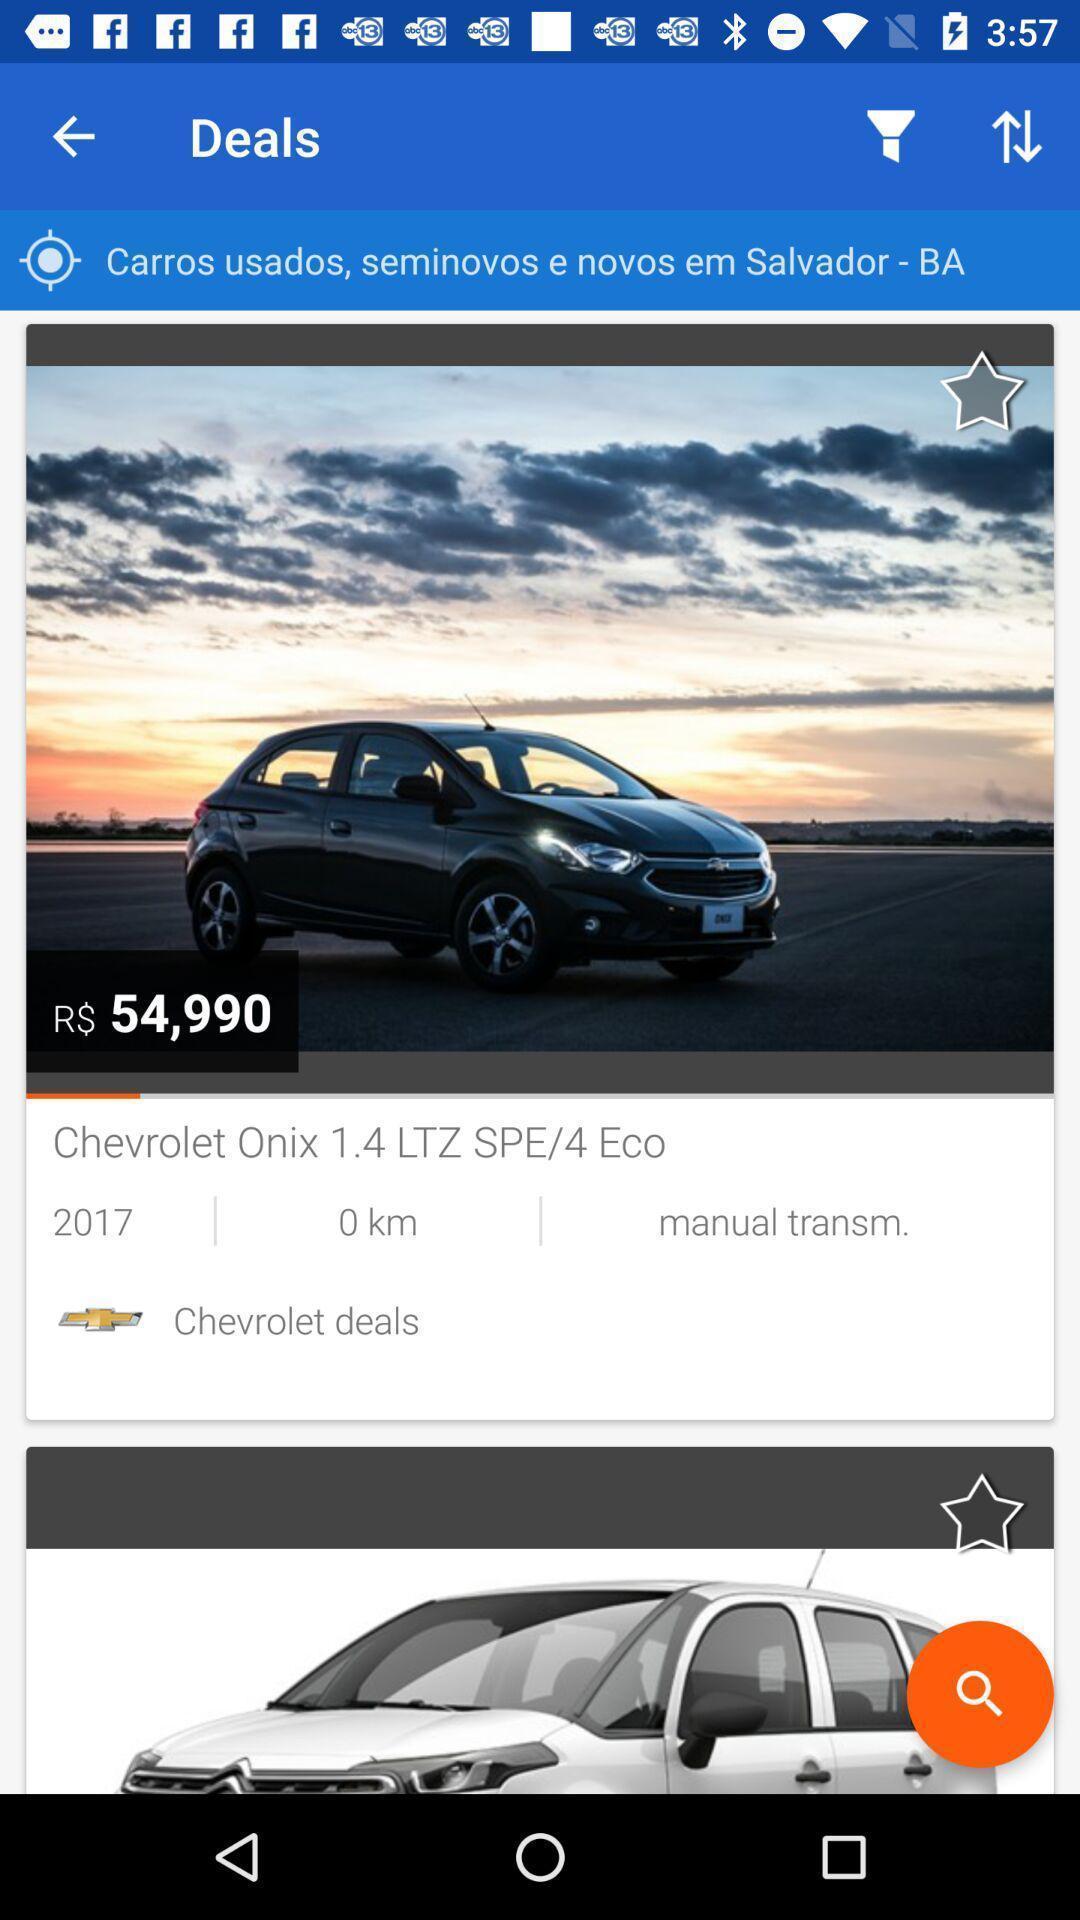Provide a detailed account of this screenshot. Screen displaying the car images and its features. 